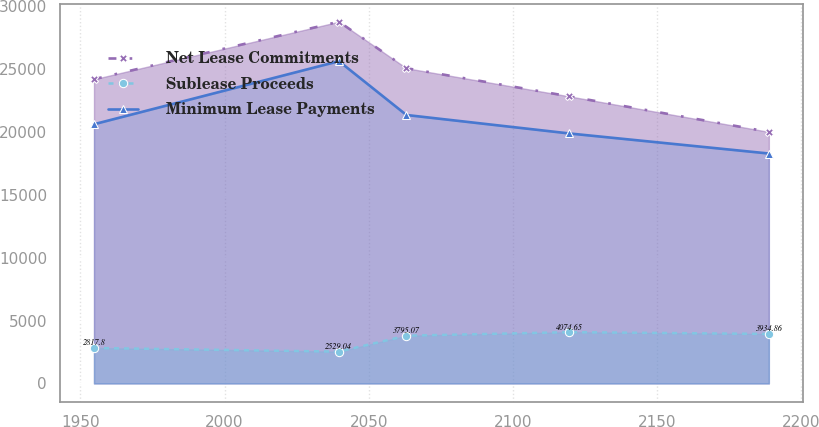Convert chart to OTSL. <chart><loc_0><loc_0><loc_500><loc_500><line_chart><ecel><fcel>Net Lease Commitments<fcel>Sublease Proceeds<fcel>Minimum Lease Payments<nl><fcel>1954.72<fcel>24166.2<fcel>2817.8<fcel>20590.5<nl><fcel>2039.66<fcel>28731.4<fcel>2529.04<fcel>25598.1<nl><fcel>2063.06<fcel>25041<fcel>3795.07<fcel>21323.9<nl><fcel>2119.56<fcel>22803.9<fcel>4074.65<fcel>19857<nl><fcel>2188.76<fcel>19983.3<fcel>3934.86<fcel>18263.6<nl></chart> 